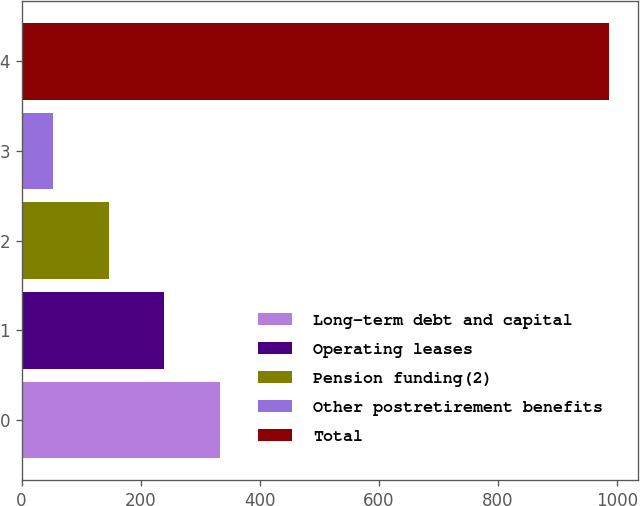<chart> <loc_0><loc_0><loc_500><loc_500><bar_chart><fcel>Long-term debt and capital<fcel>Operating leases<fcel>Pension funding(2)<fcel>Other postretirement benefits<fcel>Total<nl><fcel>332.9<fcel>239.6<fcel>146.3<fcel>53<fcel>986<nl></chart> 